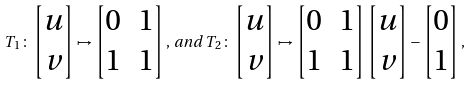Convert formula to latex. <formula><loc_0><loc_0><loc_500><loc_500>T _ { 1 } \colon \begin{bmatrix} u \\ v \end{bmatrix} \mapsto \begin{bmatrix} 0 & 1 \\ 1 & 1 \end{bmatrix} , \, a n d \, T _ { 2 } \colon \begin{bmatrix} u \\ v \end{bmatrix} \mapsto \begin{bmatrix} 0 & 1 \\ 1 & 1 \end{bmatrix} \begin{bmatrix} u \\ v \end{bmatrix} - \begin{bmatrix} 0 \\ 1 \end{bmatrix} ,</formula> 